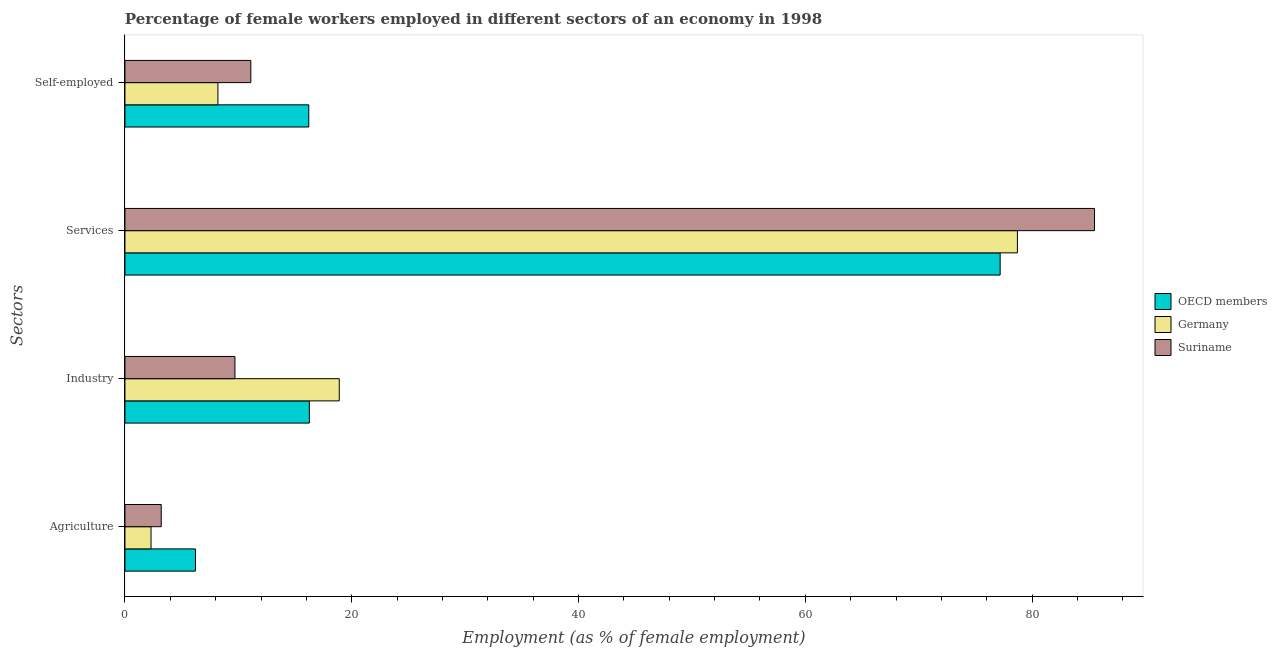How many different coloured bars are there?
Provide a succinct answer. 3. Are the number of bars on each tick of the Y-axis equal?
Ensure brevity in your answer.  Yes. How many bars are there on the 1st tick from the top?
Give a very brief answer. 3. How many bars are there on the 4th tick from the bottom?
Your response must be concise. 3. What is the label of the 1st group of bars from the top?
Provide a succinct answer. Self-employed. What is the percentage of female workers in agriculture in OECD members?
Make the answer very short. 6.22. Across all countries, what is the maximum percentage of self employed female workers?
Offer a terse response. 16.21. Across all countries, what is the minimum percentage of female workers in agriculture?
Your answer should be compact. 2.3. In which country was the percentage of female workers in industry maximum?
Keep it short and to the point. Germany. In which country was the percentage of self employed female workers minimum?
Ensure brevity in your answer.  Germany. What is the total percentage of self employed female workers in the graph?
Your response must be concise. 35.51. What is the difference between the percentage of female workers in industry in Suriname and that in OECD members?
Keep it short and to the point. -6.56. What is the difference between the percentage of self employed female workers in Germany and the percentage of female workers in agriculture in Suriname?
Keep it short and to the point. 5. What is the average percentage of female workers in services per country?
Offer a very short reply. 80.46. What is the difference between the percentage of female workers in industry and percentage of female workers in agriculture in Suriname?
Your answer should be compact. 6.5. In how many countries, is the percentage of female workers in services greater than 68 %?
Ensure brevity in your answer.  3. What is the ratio of the percentage of female workers in agriculture in Suriname to that in OECD members?
Ensure brevity in your answer.  0.51. Is the percentage of female workers in services in OECD members less than that in Germany?
Your answer should be very brief. Yes. Is the difference between the percentage of female workers in industry in Suriname and OECD members greater than the difference between the percentage of self employed female workers in Suriname and OECD members?
Your answer should be compact. No. What is the difference between the highest and the second highest percentage of self employed female workers?
Provide a succinct answer. 5.11. What is the difference between the highest and the lowest percentage of self employed female workers?
Provide a succinct answer. 8.01. Is it the case that in every country, the sum of the percentage of self employed female workers and percentage of female workers in industry is greater than the sum of percentage of female workers in agriculture and percentage of female workers in services?
Ensure brevity in your answer.  No. How many bars are there?
Your answer should be very brief. 12. What is the difference between two consecutive major ticks on the X-axis?
Provide a succinct answer. 20. Are the values on the major ticks of X-axis written in scientific E-notation?
Keep it short and to the point. No. What is the title of the graph?
Offer a terse response. Percentage of female workers employed in different sectors of an economy in 1998. Does "Mozambique" appear as one of the legend labels in the graph?
Provide a succinct answer. No. What is the label or title of the X-axis?
Your response must be concise. Employment (as % of female employment). What is the label or title of the Y-axis?
Give a very brief answer. Sectors. What is the Employment (as % of female employment) in OECD members in Agriculture?
Make the answer very short. 6.22. What is the Employment (as % of female employment) of Germany in Agriculture?
Provide a short and direct response. 2.3. What is the Employment (as % of female employment) of Suriname in Agriculture?
Provide a short and direct response. 3.2. What is the Employment (as % of female employment) of OECD members in Industry?
Give a very brief answer. 16.26. What is the Employment (as % of female employment) of Germany in Industry?
Give a very brief answer. 18.9. What is the Employment (as % of female employment) of Suriname in Industry?
Offer a very short reply. 9.7. What is the Employment (as % of female employment) in OECD members in Services?
Offer a very short reply. 77.18. What is the Employment (as % of female employment) in Germany in Services?
Make the answer very short. 78.7. What is the Employment (as % of female employment) of Suriname in Services?
Make the answer very short. 85.5. What is the Employment (as % of female employment) in OECD members in Self-employed?
Make the answer very short. 16.21. What is the Employment (as % of female employment) in Germany in Self-employed?
Offer a very short reply. 8.2. What is the Employment (as % of female employment) in Suriname in Self-employed?
Ensure brevity in your answer.  11.1. Across all Sectors, what is the maximum Employment (as % of female employment) of OECD members?
Make the answer very short. 77.18. Across all Sectors, what is the maximum Employment (as % of female employment) in Germany?
Offer a terse response. 78.7. Across all Sectors, what is the maximum Employment (as % of female employment) in Suriname?
Make the answer very short. 85.5. Across all Sectors, what is the minimum Employment (as % of female employment) of OECD members?
Provide a succinct answer. 6.22. Across all Sectors, what is the minimum Employment (as % of female employment) of Germany?
Give a very brief answer. 2.3. Across all Sectors, what is the minimum Employment (as % of female employment) in Suriname?
Make the answer very short. 3.2. What is the total Employment (as % of female employment) of OECD members in the graph?
Give a very brief answer. 115.87. What is the total Employment (as % of female employment) of Germany in the graph?
Give a very brief answer. 108.1. What is the total Employment (as % of female employment) of Suriname in the graph?
Provide a succinct answer. 109.5. What is the difference between the Employment (as % of female employment) of OECD members in Agriculture and that in Industry?
Provide a short and direct response. -10.04. What is the difference between the Employment (as % of female employment) of Germany in Agriculture and that in Industry?
Keep it short and to the point. -16.6. What is the difference between the Employment (as % of female employment) of Suriname in Agriculture and that in Industry?
Provide a short and direct response. -6.5. What is the difference between the Employment (as % of female employment) of OECD members in Agriculture and that in Services?
Keep it short and to the point. -70.96. What is the difference between the Employment (as % of female employment) of Germany in Agriculture and that in Services?
Ensure brevity in your answer.  -76.4. What is the difference between the Employment (as % of female employment) in Suriname in Agriculture and that in Services?
Ensure brevity in your answer.  -82.3. What is the difference between the Employment (as % of female employment) of OECD members in Agriculture and that in Self-employed?
Provide a short and direct response. -9.99. What is the difference between the Employment (as % of female employment) in Suriname in Agriculture and that in Self-employed?
Your answer should be very brief. -7.9. What is the difference between the Employment (as % of female employment) in OECD members in Industry and that in Services?
Offer a very short reply. -60.92. What is the difference between the Employment (as % of female employment) in Germany in Industry and that in Services?
Your response must be concise. -59.8. What is the difference between the Employment (as % of female employment) in Suriname in Industry and that in Services?
Ensure brevity in your answer.  -75.8. What is the difference between the Employment (as % of female employment) in OECD members in Industry and that in Self-employed?
Make the answer very short. 0.05. What is the difference between the Employment (as % of female employment) in Suriname in Industry and that in Self-employed?
Give a very brief answer. -1.4. What is the difference between the Employment (as % of female employment) in OECD members in Services and that in Self-employed?
Keep it short and to the point. 60.97. What is the difference between the Employment (as % of female employment) of Germany in Services and that in Self-employed?
Your answer should be very brief. 70.5. What is the difference between the Employment (as % of female employment) in Suriname in Services and that in Self-employed?
Your response must be concise. 74.4. What is the difference between the Employment (as % of female employment) of OECD members in Agriculture and the Employment (as % of female employment) of Germany in Industry?
Provide a succinct answer. -12.68. What is the difference between the Employment (as % of female employment) of OECD members in Agriculture and the Employment (as % of female employment) of Suriname in Industry?
Ensure brevity in your answer.  -3.48. What is the difference between the Employment (as % of female employment) in OECD members in Agriculture and the Employment (as % of female employment) in Germany in Services?
Ensure brevity in your answer.  -72.48. What is the difference between the Employment (as % of female employment) in OECD members in Agriculture and the Employment (as % of female employment) in Suriname in Services?
Offer a very short reply. -79.28. What is the difference between the Employment (as % of female employment) of Germany in Agriculture and the Employment (as % of female employment) of Suriname in Services?
Offer a terse response. -83.2. What is the difference between the Employment (as % of female employment) of OECD members in Agriculture and the Employment (as % of female employment) of Germany in Self-employed?
Keep it short and to the point. -1.98. What is the difference between the Employment (as % of female employment) of OECD members in Agriculture and the Employment (as % of female employment) of Suriname in Self-employed?
Offer a very short reply. -4.88. What is the difference between the Employment (as % of female employment) in Germany in Agriculture and the Employment (as % of female employment) in Suriname in Self-employed?
Your answer should be compact. -8.8. What is the difference between the Employment (as % of female employment) in OECD members in Industry and the Employment (as % of female employment) in Germany in Services?
Keep it short and to the point. -62.44. What is the difference between the Employment (as % of female employment) of OECD members in Industry and the Employment (as % of female employment) of Suriname in Services?
Ensure brevity in your answer.  -69.24. What is the difference between the Employment (as % of female employment) of Germany in Industry and the Employment (as % of female employment) of Suriname in Services?
Offer a terse response. -66.6. What is the difference between the Employment (as % of female employment) of OECD members in Industry and the Employment (as % of female employment) of Germany in Self-employed?
Keep it short and to the point. 8.06. What is the difference between the Employment (as % of female employment) of OECD members in Industry and the Employment (as % of female employment) of Suriname in Self-employed?
Make the answer very short. 5.16. What is the difference between the Employment (as % of female employment) in OECD members in Services and the Employment (as % of female employment) in Germany in Self-employed?
Provide a succinct answer. 68.98. What is the difference between the Employment (as % of female employment) of OECD members in Services and the Employment (as % of female employment) of Suriname in Self-employed?
Provide a succinct answer. 66.08. What is the difference between the Employment (as % of female employment) in Germany in Services and the Employment (as % of female employment) in Suriname in Self-employed?
Ensure brevity in your answer.  67.6. What is the average Employment (as % of female employment) of OECD members per Sectors?
Your response must be concise. 28.97. What is the average Employment (as % of female employment) of Germany per Sectors?
Give a very brief answer. 27.02. What is the average Employment (as % of female employment) in Suriname per Sectors?
Offer a terse response. 27.38. What is the difference between the Employment (as % of female employment) in OECD members and Employment (as % of female employment) in Germany in Agriculture?
Offer a terse response. 3.92. What is the difference between the Employment (as % of female employment) of OECD members and Employment (as % of female employment) of Suriname in Agriculture?
Your response must be concise. 3.02. What is the difference between the Employment (as % of female employment) in Germany and Employment (as % of female employment) in Suriname in Agriculture?
Provide a succinct answer. -0.9. What is the difference between the Employment (as % of female employment) of OECD members and Employment (as % of female employment) of Germany in Industry?
Make the answer very short. -2.64. What is the difference between the Employment (as % of female employment) in OECD members and Employment (as % of female employment) in Suriname in Industry?
Your answer should be compact. 6.56. What is the difference between the Employment (as % of female employment) of OECD members and Employment (as % of female employment) of Germany in Services?
Make the answer very short. -1.52. What is the difference between the Employment (as % of female employment) of OECD members and Employment (as % of female employment) of Suriname in Services?
Your answer should be very brief. -8.32. What is the difference between the Employment (as % of female employment) in OECD members and Employment (as % of female employment) in Germany in Self-employed?
Provide a succinct answer. 8.01. What is the difference between the Employment (as % of female employment) in OECD members and Employment (as % of female employment) in Suriname in Self-employed?
Ensure brevity in your answer.  5.11. What is the ratio of the Employment (as % of female employment) of OECD members in Agriculture to that in Industry?
Your answer should be compact. 0.38. What is the ratio of the Employment (as % of female employment) in Germany in Agriculture to that in Industry?
Provide a short and direct response. 0.12. What is the ratio of the Employment (as % of female employment) of Suriname in Agriculture to that in Industry?
Make the answer very short. 0.33. What is the ratio of the Employment (as % of female employment) in OECD members in Agriculture to that in Services?
Ensure brevity in your answer.  0.08. What is the ratio of the Employment (as % of female employment) in Germany in Agriculture to that in Services?
Your answer should be very brief. 0.03. What is the ratio of the Employment (as % of female employment) of Suriname in Agriculture to that in Services?
Offer a very short reply. 0.04. What is the ratio of the Employment (as % of female employment) of OECD members in Agriculture to that in Self-employed?
Your answer should be very brief. 0.38. What is the ratio of the Employment (as % of female employment) in Germany in Agriculture to that in Self-employed?
Your response must be concise. 0.28. What is the ratio of the Employment (as % of female employment) of Suriname in Agriculture to that in Self-employed?
Provide a succinct answer. 0.29. What is the ratio of the Employment (as % of female employment) of OECD members in Industry to that in Services?
Keep it short and to the point. 0.21. What is the ratio of the Employment (as % of female employment) of Germany in Industry to that in Services?
Provide a succinct answer. 0.24. What is the ratio of the Employment (as % of female employment) in Suriname in Industry to that in Services?
Offer a very short reply. 0.11. What is the ratio of the Employment (as % of female employment) in Germany in Industry to that in Self-employed?
Your response must be concise. 2.3. What is the ratio of the Employment (as % of female employment) in Suriname in Industry to that in Self-employed?
Make the answer very short. 0.87. What is the ratio of the Employment (as % of female employment) of OECD members in Services to that in Self-employed?
Make the answer very short. 4.76. What is the ratio of the Employment (as % of female employment) in Germany in Services to that in Self-employed?
Give a very brief answer. 9.6. What is the ratio of the Employment (as % of female employment) of Suriname in Services to that in Self-employed?
Ensure brevity in your answer.  7.7. What is the difference between the highest and the second highest Employment (as % of female employment) of OECD members?
Offer a very short reply. 60.92. What is the difference between the highest and the second highest Employment (as % of female employment) in Germany?
Keep it short and to the point. 59.8. What is the difference between the highest and the second highest Employment (as % of female employment) of Suriname?
Give a very brief answer. 74.4. What is the difference between the highest and the lowest Employment (as % of female employment) in OECD members?
Provide a short and direct response. 70.96. What is the difference between the highest and the lowest Employment (as % of female employment) in Germany?
Give a very brief answer. 76.4. What is the difference between the highest and the lowest Employment (as % of female employment) in Suriname?
Your response must be concise. 82.3. 